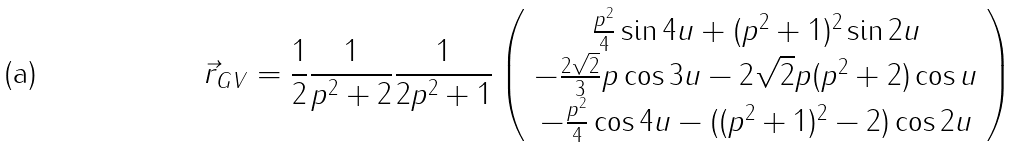Convert formula to latex. <formula><loc_0><loc_0><loc_500><loc_500>\vec { r } _ { G V } = { \frac { 1 } { 2 } } { \frac { 1 } { p ^ { 2 } + 2 } } { \frac { 1 } { 2 p ^ { 2 } + 1 } } \left ( \begin{array} { c } { { { \frac { p ^ { 2 } } { 4 } } \sin { 4 u } + ( p ^ { 2 } + 1 ) ^ { 2 } \sin { 2 u } } } \\ { { - { \frac { 2 \sqrt { 2 } } { 3 } } p \cos { 3 u } - 2 \sqrt { 2 } p ( p ^ { 2 } + 2 ) \cos { u } } } \\ { { - { \frac { p ^ { 2 } } { 4 } } \cos { 4 u } - ( ( p ^ { 2 } + 1 ) ^ { 2 } - 2 ) \cos { 2 u } } } \end{array} \right )</formula> 